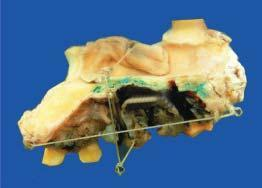what does the hemimaxillectomy specimen show?
Answer the question using a single word or phrase. Elevated blackish ulcerated area with irregular outlines 